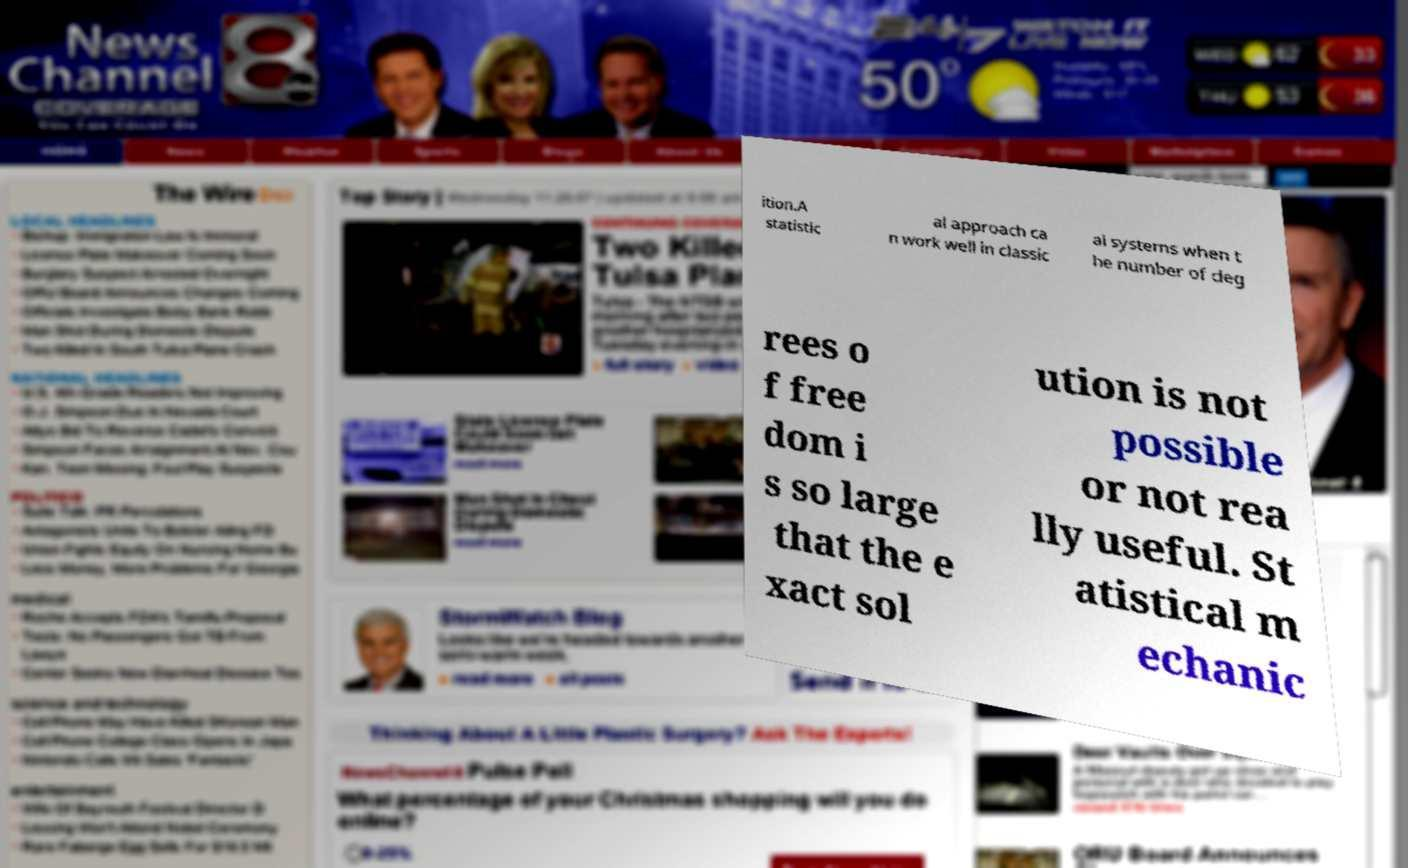Can you read and provide the text displayed in the image?This photo seems to have some interesting text. Can you extract and type it out for me? ition.A statistic al approach ca n work well in classic al systems when t he number of deg rees o f free dom i s so large that the e xact sol ution is not possible or not rea lly useful. St atistical m echanic 